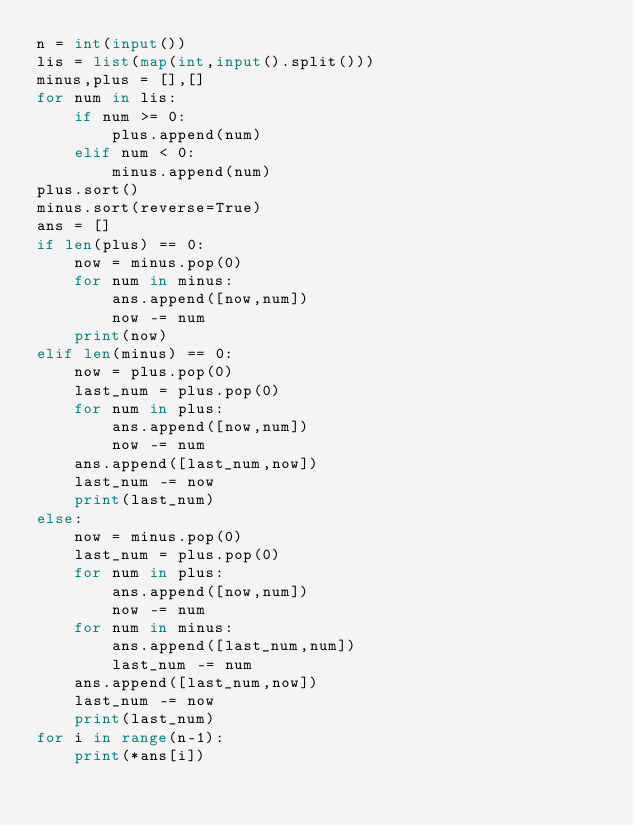<code> <loc_0><loc_0><loc_500><loc_500><_Python_>n = int(input())
lis = list(map(int,input().split()))
minus,plus = [],[]
for num in lis:
    if num >= 0:
        plus.append(num)
    elif num < 0:
        minus.append(num)
plus.sort()
minus.sort(reverse=True)
ans = []
if len(plus) == 0:
    now = minus.pop(0)
    for num in minus:
        ans.append([now,num])
        now -= num
    print(now)
elif len(minus) == 0:
    now = plus.pop(0)
    last_num = plus.pop(0)
    for num in plus:
        ans.append([now,num])
        now -= num
    ans.append([last_num,now])
    last_num -= now
    print(last_num)
else:
    now = minus.pop(0)
    last_num = plus.pop(0)
    for num in plus:
        ans.append([now,num])
        now -= num
    for num in minus:
        ans.append([last_num,num])
        last_num -= num
    ans.append([last_num,now])
    last_num -= now
    print(last_num)
for i in range(n-1):
    print(*ans[i])</code> 